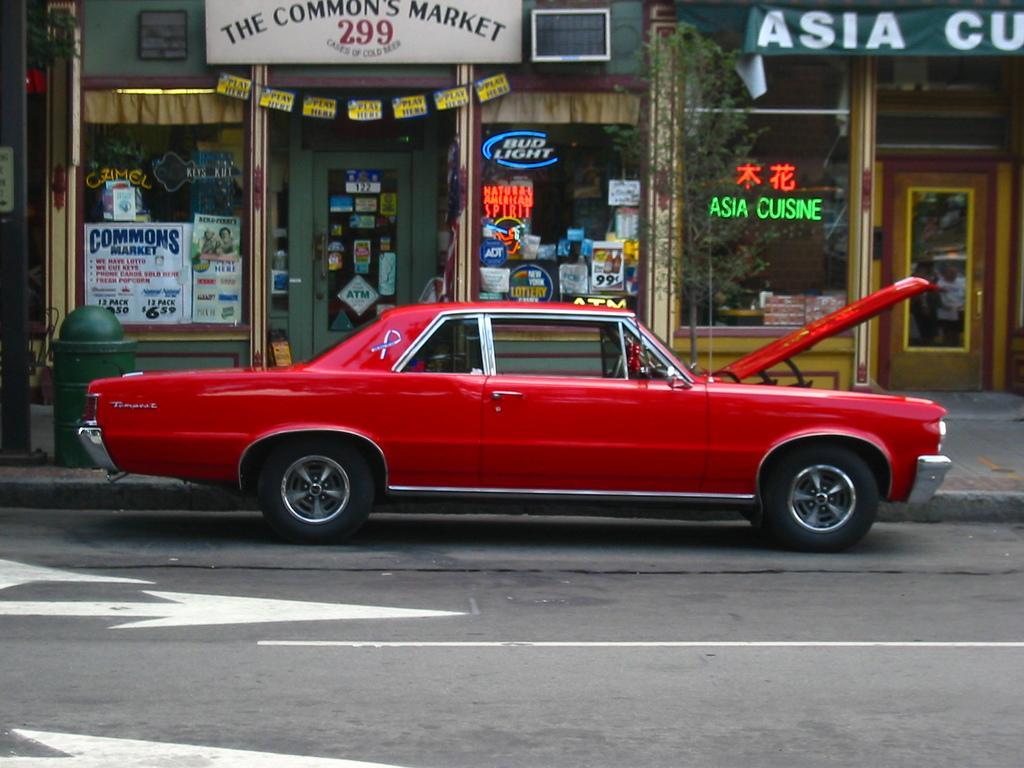Describe this image in one or two sentences. In this picture we can see a red car on the road, posters, banners, name board and some objects. 